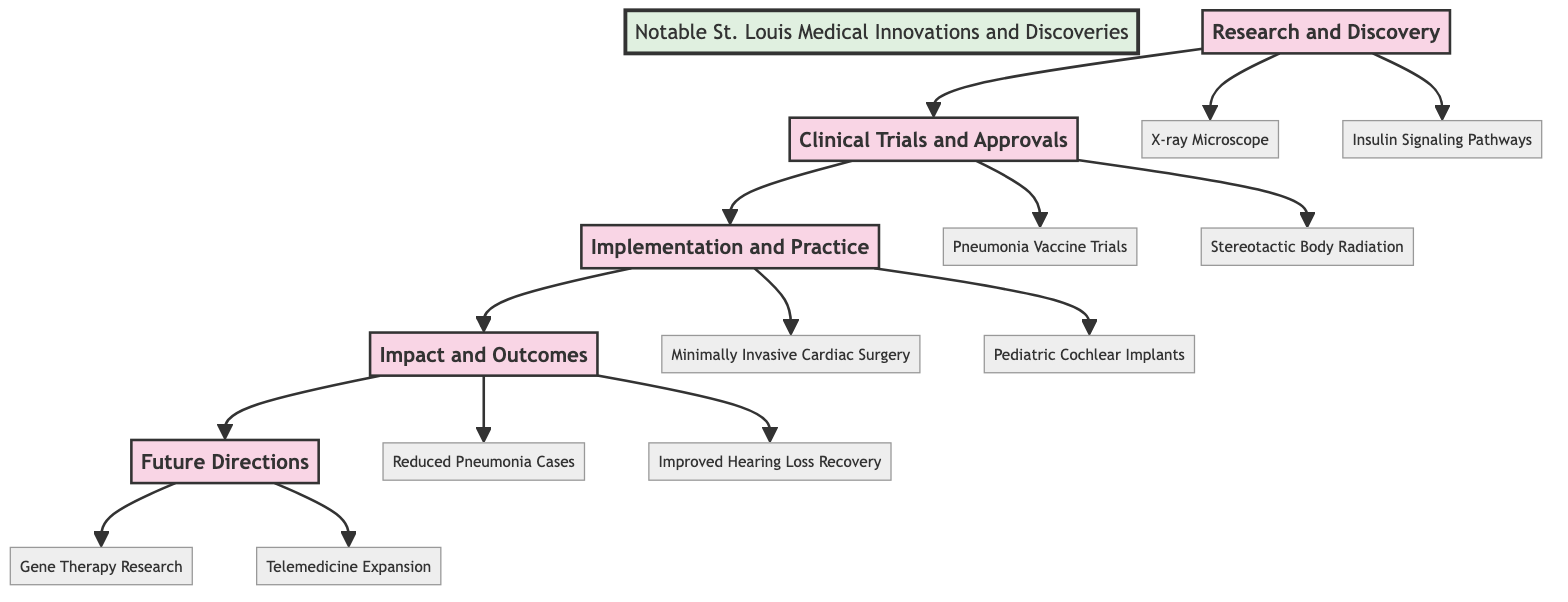What are the two key innovations in Research and Discovery? The diagram lists two specific innovations under the Research and Discovery stage: "Development of X-ray Microscope at Washington University School of Medicine" and "Discovery of Insulin Signaling Pathways by Dr. Everson Pearse at St. Louis University."
Answer: Development of X-ray Microscope, Discovery of Insulin Signaling Pathways How many stages are represented in the diagram? The diagram shows five distinct stages: Research and Discovery, Clinical Trials and Approvals, Implementation and Practice, Impact and Outcomes, and Future Directions. Thus, the total number of stages is five.
Answer: 5 Which key innovation comes after Clinical Trials and Approvals? Following the Clinical Trials and Approvals stage, the next stage in the diagram is Implementation and Practice, where the key innovations are specified.
Answer: Implementation and Practice What impact is noted as a result of the vaccine introduction? The diagram clearly states an impact resulting from the vaccine introduction, specifically "Reduction in Local Pneumonia Cases Due to Vaccine Introduction." This reflects the positive outcome of the related innovation.
Answer: Reduction in Local Pneumonia Cases Which future direction involves ongoing research? According to the diagram, the ongoing research effort within the Future Directions stage is identified as "Ongoing Gene Therapy Research at Washington University in St. Louis." This indicates a focus on advancing gene therapy.
Answer: Ongoing Gene Therapy Research What links the Implementation and Practice to Impact and Outcomes? The relationship between Implementation and Practice and Impact and Outcomes is established through the flow of innovations; specifically, both stages include innovations that lead to improved health outcomes. Innovations in Implementation lead to the impacts noted in Outcomes.
Answer: Innovations lead to health impacts Which hospital is associated with the first human trials of a pneumonia vaccine? The diagram specifies that "First Human Trials of the Pneumonia Vaccine" were conducted at "Barnes-Jewish Hospital," which identifies where this particular clinical trial took place.
Answer: Barnes-Jewish Hospital 